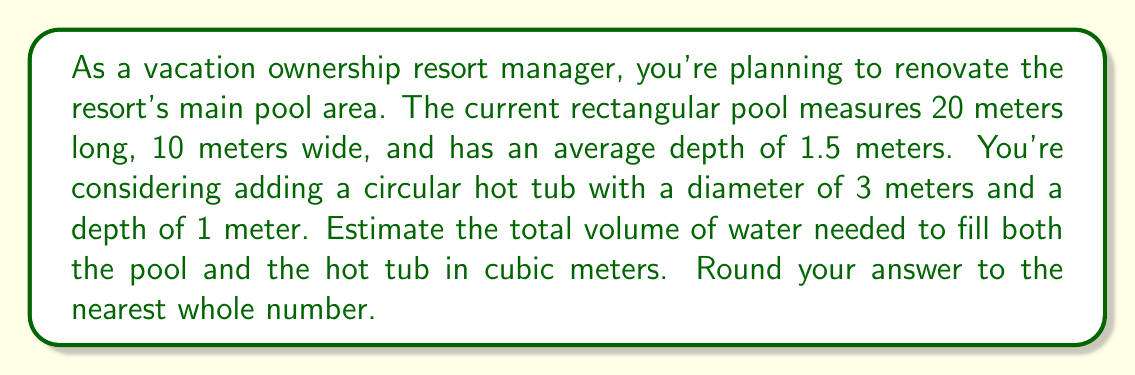Can you answer this question? To solve this problem, we need to calculate the volumes of both the pool and the hot tub separately, then add them together.

1. Calculate the volume of the rectangular pool:
   The formula for the volume of a rectangular prism is:
   $$V_{pool} = length \times width \times depth$$
   $$V_{pool} = 20 \text{ m} \times 10 \text{ m} \times 1.5 \text{ m} = 300 \text{ m}^3$$

2. Calculate the volume of the circular hot tub:
   The formula for the volume of a cylinder (which is the shape of the hot tub) is:
   $$V_{hot tub} = \pi r^2 h$$
   where $r$ is the radius and $h$ is the height (depth)
   
   The diameter is 3 m, so the radius is 1.5 m:
   $$V_{hot tub} = \pi \times (1.5 \text{ m})^2 \times 1 \text{ m} \approx 7.0686 \text{ m}^3$$

3. Calculate the total volume:
   $$V_{total} = V_{pool} + V_{hot tub}$$
   $$V_{total} = 300 \text{ m}^3 + 7.0686 \text{ m}^3 = 307.0686 \text{ m}^3$$

4. Round to the nearest whole number:
   307.0686 rounds to 307 cubic meters.
Answer: The total volume of water needed to fill both the pool and the hot tub is approximately 307 cubic meters. 